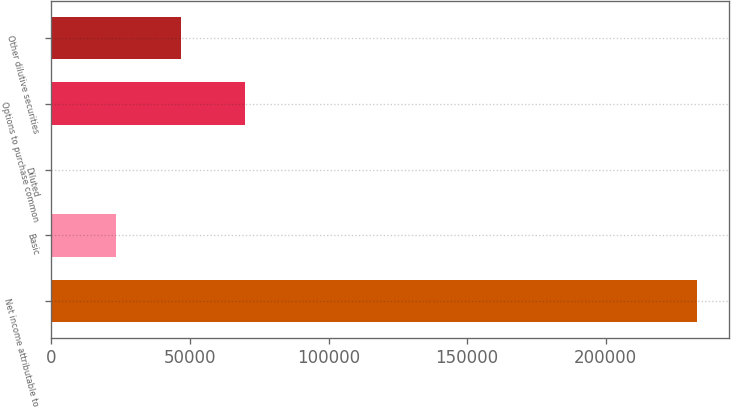<chart> <loc_0><loc_0><loc_500><loc_500><bar_chart><fcel>Net income attributable to<fcel>Basic<fcel>Diluted<fcel>Options to purchase common<fcel>Other dilutive securities<nl><fcel>232850<fcel>23286.5<fcel>1.67<fcel>69856.2<fcel>46571.3<nl></chart> 